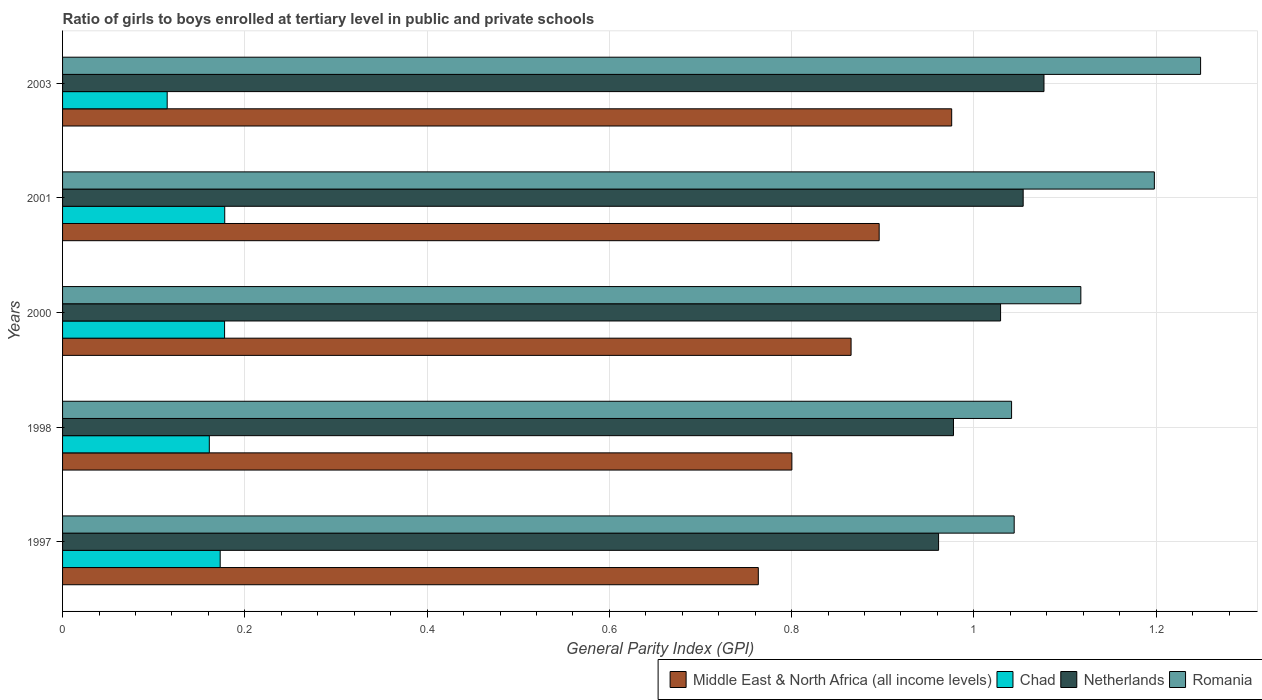Are the number of bars per tick equal to the number of legend labels?
Give a very brief answer. Yes. How many bars are there on the 4th tick from the top?
Provide a succinct answer. 4. How many bars are there on the 5th tick from the bottom?
Give a very brief answer. 4. What is the label of the 5th group of bars from the top?
Give a very brief answer. 1997. In how many cases, is the number of bars for a given year not equal to the number of legend labels?
Offer a terse response. 0. What is the general parity index in Chad in 2000?
Provide a short and direct response. 0.18. Across all years, what is the maximum general parity index in Romania?
Give a very brief answer. 1.25. Across all years, what is the minimum general parity index in Netherlands?
Your answer should be compact. 0.96. What is the total general parity index in Netherlands in the graph?
Your response must be concise. 5.1. What is the difference between the general parity index in Romania in 1997 and that in 2000?
Make the answer very short. -0.07. What is the difference between the general parity index in Middle East & North Africa (all income levels) in 1998 and the general parity index in Romania in 2001?
Your answer should be very brief. -0.4. What is the average general parity index in Middle East & North Africa (all income levels) per year?
Offer a very short reply. 0.86. In the year 2001, what is the difference between the general parity index in Middle East & North Africa (all income levels) and general parity index in Netherlands?
Your answer should be very brief. -0.16. What is the ratio of the general parity index in Romania in 1997 to that in 2000?
Offer a very short reply. 0.93. What is the difference between the highest and the second highest general parity index in Middle East & North Africa (all income levels)?
Your answer should be very brief. 0.08. What is the difference between the highest and the lowest general parity index in Chad?
Your answer should be compact. 0.06. In how many years, is the general parity index in Chad greater than the average general parity index in Chad taken over all years?
Your answer should be very brief. 4. What does the 3rd bar from the top in 2000 represents?
Ensure brevity in your answer.  Chad. What does the 2nd bar from the bottom in 2000 represents?
Offer a terse response. Chad. How many bars are there?
Your answer should be compact. 20. What is the difference between two consecutive major ticks on the X-axis?
Provide a succinct answer. 0.2. Are the values on the major ticks of X-axis written in scientific E-notation?
Your response must be concise. No. Does the graph contain any zero values?
Offer a terse response. No. Does the graph contain grids?
Provide a short and direct response. Yes. Where does the legend appear in the graph?
Your response must be concise. Bottom right. How are the legend labels stacked?
Offer a very short reply. Horizontal. What is the title of the graph?
Your response must be concise. Ratio of girls to boys enrolled at tertiary level in public and private schools. Does "Burundi" appear as one of the legend labels in the graph?
Your answer should be compact. No. What is the label or title of the X-axis?
Offer a terse response. General Parity Index (GPI). What is the label or title of the Y-axis?
Make the answer very short. Years. What is the General Parity Index (GPI) of Middle East & North Africa (all income levels) in 1997?
Offer a very short reply. 0.76. What is the General Parity Index (GPI) of Chad in 1997?
Your answer should be compact. 0.17. What is the General Parity Index (GPI) of Netherlands in 1997?
Your answer should be compact. 0.96. What is the General Parity Index (GPI) in Romania in 1997?
Give a very brief answer. 1.04. What is the General Parity Index (GPI) of Middle East & North Africa (all income levels) in 1998?
Give a very brief answer. 0.8. What is the General Parity Index (GPI) of Chad in 1998?
Your answer should be compact. 0.16. What is the General Parity Index (GPI) in Netherlands in 1998?
Your response must be concise. 0.98. What is the General Parity Index (GPI) in Romania in 1998?
Your answer should be very brief. 1.04. What is the General Parity Index (GPI) in Middle East & North Africa (all income levels) in 2000?
Give a very brief answer. 0.87. What is the General Parity Index (GPI) of Chad in 2000?
Your answer should be very brief. 0.18. What is the General Parity Index (GPI) of Netherlands in 2000?
Provide a short and direct response. 1.03. What is the General Parity Index (GPI) of Romania in 2000?
Your response must be concise. 1.12. What is the General Parity Index (GPI) in Middle East & North Africa (all income levels) in 2001?
Your answer should be very brief. 0.9. What is the General Parity Index (GPI) of Chad in 2001?
Your answer should be compact. 0.18. What is the General Parity Index (GPI) of Netherlands in 2001?
Your answer should be very brief. 1.05. What is the General Parity Index (GPI) in Romania in 2001?
Offer a very short reply. 1.2. What is the General Parity Index (GPI) in Middle East & North Africa (all income levels) in 2003?
Your answer should be very brief. 0.98. What is the General Parity Index (GPI) in Chad in 2003?
Offer a terse response. 0.11. What is the General Parity Index (GPI) in Netherlands in 2003?
Your answer should be compact. 1.08. What is the General Parity Index (GPI) in Romania in 2003?
Ensure brevity in your answer.  1.25. Across all years, what is the maximum General Parity Index (GPI) of Middle East & North Africa (all income levels)?
Your answer should be very brief. 0.98. Across all years, what is the maximum General Parity Index (GPI) of Chad?
Provide a short and direct response. 0.18. Across all years, what is the maximum General Parity Index (GPI) in Netherlands?
Provide a succinct answer. 1.08. Across all years, what is the maximum General Parity Index (GPI) of Romania?
Provide a succinct answer. 1.25. Across all years, what is the minimum General Parity Index (GPI) of Middle East & North Africa (all income levels)?
Keep it short and to the point. 0.76. Across all years, what is the minimum General Parity Index (GPI) of Chad?
Provide a short and direct response. 0.11. Across all years, what is the minimum General Parity Index (GPI) of Netherlands?
Keep it short and to the point. 0.96. Across all years, what is the minimum General Parity Index (GPI) in Romania?
Offer a terse response. 1.04. What is the total General Parity Index (GPI) of Middle East & North Africa (all income levels) in the graph?
Your answer should be compact. 4.3. What is the total General Parity Index (GPI) in Chad in the graph?
Provide a short and direct response. 0.8. What is the total General Parity Index (GPI) of Netherlands in the graph?
Your answer should be compact. 5.1. What is the total General Parity Index (GPI) in Romania in the graph?
Provide a short and direct response. 5.65. What is the difference between the General Parity Index (GPI) in Middle East & North Africa (all income levels) in 1997 and that in 1998?
Offer a very short reply. -0.04. What is the difference between the General Parity Index (GPI) of Chad in 1997 and that in 1998?
Provide a short and direct response. 0.01. What is the difference between the General Parity Index (GPI) of Netherlands in 1997 and that in 1998?
Provide a succinct answer. -0.02. What is the difference between the General Parity Index (GPI) of Romania in 1997 and that in 1998?
Keep it short and to the point. 0. What is the difference between the General Parity Index (GPI) in Middle East & North Africa (all income levels) in 1997 and that in 2000?
Your answer should be compact. -0.1. What is the difference between the General Parity Index (GPI) of Chad in 1997 and that in 2000?
Provide a succinct answer. -0. What is the difference between the General Parity Index (GPI) in Netherlands in 1997 and that in 2000?
Keep it short and to the point. -0.07. What is the difference between the General Parity Index (GPI) in Romania in 1997 and that in 2000?
Give a very brief answer. -0.07. What is the difference between the General Parity Index (GPI) of Middle East & North Africa (all income levels) in 1997 and that in 2001?
Your answer should be compact. -0.13. What is the difference between the General Parity Index (GPI) in Chad in 1997 and that in 2001?
Provide a succinct answer. -0.01. What is the difference between the General Parity Index (GPI) in Netherlands in 1997 and that in 2001?
Provide a short and direct response. -0.09. What is the difference between the General Parity Index (GPI) in Romania in 1997 and that in 2001?
Your answer should be compact. -0.15. What is the difference between the General Parity Index (GPI) of Middle East & North Africa (all income levels) in 1997 and that in 2003?
Keep it short and to the point. -0.21. What is the difference between the General Parity Index (GPI) of Chad in 1997 and that in 2003?
Keep it short and to the point. 0.06. What is the difference between the General Parity Index (GPI) in Netherlands in 1997 and that in 2003?
Make the answer very short. -0.12. What is the difference between the General Parity Index (GPI) of Romania in 1997 and that in 2003?
Provide a short and direct response. -0.2. What is the difference between the General Parity Index (GPI) in Middle East & North Africa (all income levels) in 1998 and that in 2000?
Provide a succinct answer. -0.07. What is the difference between the General Parity Index (GPI) of Chad in 1998 and that in 2000?
Your answer should be very brief. -0.02. What is the difference between the General Parity Index (GPI) of Netherlands in 1998 and that in 2000?
Your answer should be compact. -0.05. What is the difference between the General Parity Index (GPI) in Romania in 1998 and that in 2000?
Your answer should be very brief. -0.08. What is the difference between the General Parity Index (GPI) in Middle East & North Africa (all income levels) in 1998 and that in 2001?
Offer a terse response. -0.1. What is the difference between the General Parity Index (GPI) in Chad in 1998 and that in 2001?
Offer a terse response. -0.02. What is the difference between the General Parity Index (GPI) of Netherlands in 1998 and that in 2001?
Your answer should be compact. -0.08. What is the difference between the General Parity Index (GPI) of Romania in 1998 and that in 2001?
Your answer should be very brief. -0.16. What is the difference between the General Parity Index (GPI) in Middle East & North Africa (all income levels) in 1998 and that in 2003?
Provide a short and direct response. -0.18. What is the difference between the General Parity Index (GPI) of Chad in 1998 and that in 2003?
Make the answer very short. 0.05. What is the difference between the General Parity Index (GPI) of Netherlands in 1998 and that in 2003?
Ensure brevity in your answer.  -0.1. What is the difference between the General Parity Index (GPI) in Romania in 1998 and that in 2003?
Ensure brevity in your answer.  -0.21. What is the difference between the General Parity Index (GPI) in Middle East & North Africa (all income levels) in 2000 and that in 2001?
Offer a very short reply. -0.03. What is the difference between the General Parity Index (GPI) of Chad in 2000 and that in 2001?
Your response must be concise. -0. What is the difference between the General Parity Index (GPI) in Netherlands in 2000 and that in 2001?
Offer a very short reply. -0.02. What is the difference between the General Parity Index (GPI) of Romania in 2000 and that in 2001?
Ensure brevity in your answer.  -0.08. What is the difference between the General Parity Index (GPI) of Middle East & North Africa (all income levels) in 2000 and that in 2003?
Keep it short and to the point. -0.11. What is the difference between the General Parity Index (GPI) in Chad in 2000 and that in 2003?
Give a very brief answer. 0.06. What is the difference between the General Parity Index (GPI) in Netherlands in 2000 and that in 2003?
Your answer should be very brief. -0.05. What is the difference between the General Parity Index (GPI) of Romania in 2000 and that in 2003?
Offer a terse response. -0.13. What is the difference between the General Parity Index (GPI) in Middle East & North Africa (all income levels) in 2001 and that in 2003?
Provide a succinct answer. -0.08. What is the difference between the General Parity Index (GPI) of Chad in 2001 and that in 2003?
Your answer should be very brief. 0.06. What is the difference between the General Parity Index (GPI) in Netherlands in 2001 and that in 2003?
Provide a succinct answer. -0.02. What is the difference between the General Parity Index (GPI) in Romania in 2001 and that in 2003?
Your answer should be compact. -0.05. What is the difference between the General Parity Index (GPI) in Middle East & North Africa (all income levels) in 1997 and the General Parity Index (GPI) in Chad in 1998?
Keep it short and to the point. 0.6. What is the difference between the General Parity Index (GPI) of Middle East & North Africa (all income levels) in 1997 and the General Parity Index (GPI) of Netherlands in 1998?
Offer a very short reply. -0.21. What is the difference between the General Parity Index (GPI) in Middle East & North Africa (all income levels) in 1997 and the General Parity Index (GPI) in Romania in 1998?
Provide a short and direct response. -0.28. What is the difference between the General Parity Index (GPI) of Chad in 1997 and the General Parity Index (GPI) of Netherlands in 1998?
Your answer should be compact. -0.8. What is the difference between the General Parity Index (GPI) in Chad in 1997 and the General Parity Index (GPI) in Romania in 1998?
Give a very brief answer. -0.87. What is the difference between the General Parity Index (GPI) in Netherlands in 1997 and the General Parity Index (GPI) in Romania in 1998?
Give a very brief answer. -0.08. What is the difference between the General Parity Index (GPI) in Middle East & North Africa (all income levels) in 1997 and the General Parity Index (GPI) in Chad in 2000?
Keep it short and to the point. 0.59. What is the difference between the General Parity Index (GPI) in Middle East & North Africa (all income levels) in 1997 and the General Parity Index (GPI) in Netherlands in 2000?
Your response must be concise. -0.27. What is the difference between the General Parity Index (GPI) of Middle East & North Africa (all income levels) in 1997 and the General Parity Index (GPI) of Romania in 2000?
Provide a short and direct response. -0.35. What is the difference between the General Parity Index (GPI) in Chad in 1997 and the General Parity Index (GPI) in Netherlands in 2000?
Ensure brevity in your answer.  -0.86. What is the difference between the General Parity Index (GPI) of Chad in 1997 and the General Parity Index (GPI) of Romania in 2000?
Offer a very short reply. -0.94. What is the difference between the General Parity Index (GPI) in Netherlands in 1997 and the General Parity Index (GPI) in Romania in 2000?
Provide a succinct answer. -0.16. What is the difference between the General Parity Index (GPI) of Middle East & North Africa (all income levels) in 1997 and the General Parity Index (GPI) of Chad in 2001?
Offer a very short reply. 0.59. What is the difference between the General Parity Index (GPI) in Middle East & North Africa (all income levels) in 1997 and the General Parity Index (GPI) in Netherlands in 2001?
Your answer should be very brief. -0.29. What is the difference between the General Parity Index (GPI) in Middle East & North Africa (all income levels) in 1997 and the General Parity Index (GPI) in Romania in 2001?
Keep it short and to the point. -0.43. What is the difference between the General Parity Index (GPI) of Chad in 1997 and the General Parity Index (GPI) of Netherlands in 2001?
Keep it short and to the point. -0.88. What is the difference between the General Parity Index (GPI) of Chad in 1997 and the General Parity Index (GPI) of Romania in 2001?
Your response must be concise. -1.03. What is the difference between the General Parity Index (GPI) of Netherlands in 1997 and the General Parity Index (GPI) of Romania in 2001?
Provide a succinct answer. -0.24. What is the difference between the General Parity Index (GPI) in Middle East & North Africa (all income levels) in 1997 and the General Parity Index (GPI) in Chad in 2003?
Ensure brevity in your answer.  0.65. What is the difference between the General Parity Index (GPI) of Middle East & North Africa (all income levels) in 1997 and the General Parity Index (GPI) of Netherlands in 2003?
Your answer should be compact. -0.31. What is the difference between the General Parity Index (GPI) in Middle East & North Africa (all income levels) in 1997 and the General Parity Index (GPI) in Romania in 2003?
Provide a succinct answer. -0.49. What is the difference between the General Parity Index (GPI) in Chad in 1997 and the General Parity Index (GPI) in Netherlands in 2003?
Offer a very short reply. -0.9. What is the difference between the General Parity Index (GPI) of Chad in 1997 and the General Parity Index (GPI) of Romania in 2003?
Keep it short and to the point. -1.08. What is the difference between the General Parity Index (GPI) of Netherlands in 1997 and the General Parity Index (GPI) of Romania in 2003?
Your answer should be compact. -0.29. What is the difference between the General Parity Index (GPI) of Middle East & North Africa (all income levels) in 1998 and the General Parity Index (GPI) of Chad in 2000?
Ensure brevity in your answer.  0.62. What is the difference between the General Parity Index (GPI) of Middle East & North Africa (all income levels) in 1998 and the General Parity Index (GPI) of Netherlands in 2000?
Your answer should be compact. -0.23. What is the difference between the General Parity Index (GPI) of Middle East & North Africa (all income levels) in 1998 and the General Parity Index (GPI) of Romania in 2000?
Offer a very short reply. -0.32. What is the difference between the General Parity Index (GPI) of Chad in 1998 and the General Parity Index (GPI) of Netherlands in 2000?
Offer a very short reply. -0.87. What is the difference between the General Parity Index (GPI) of Chad in 1998 and the General Parity Index (GPI) of Romania in 2000?
Your answer should be compact. -0.96. What is the difference between the General Parity Index (GPI) in Netherlands in 1998 and the General Parity Index (GPI) in Romania in 2000?
Your answer should be very brief. -0.14. What is the difference between the General Parity Index (GPI) of Middle East & North Africa (all income levels) in 1998 and the General Parity Index (GPI) of Chad in 2001?
Offer a very short reply. 0.62. What is the difference between the General Parity Index (GPI) in Middle East & North Africa (all income levels) in 1998 and the General Parity Index (GPI) in Netherlands in 2001?
Provide a succinct answer. -0.25. What is the difference between the General Parity Index (GPI) in Middle East & North Africa (all income levels) in 1998 and the General Parity Index (GPI) in Romania in 2001?
Offer a very short reply. -0.4. What is the difference between the General Parity Index (GPI) of Chad in 1998 and the General Parity Index (GPI) of Netherlands in 2001?
Make the answer very short. -0.89. What is the difference between the General Parity Index (GPI) of Chad in 1998 and the General Parity Index (GPI) of Romania in 2001?
Give a very brief answer. -1.04. What is the difference between the General Parity Index (GPI) in Netherlands in 1998 and the General Parity Index (GPI) in Romania in 2001?
Your response must be concise. -0.22. What is the difference between the General Parity Index (GPI) in Middle East & North Africa (all income levels) in 1998 and the General Parity Index (GPI) in Chad in 2003?
Give a very brief answer. 0.69. What is the difference between the General Parity Index (GPI) of Middle East & North Africa (all income levels) in 1998 and the General Parity Index (GPI) of Netherlands in 2003?
Ensure brevity in your answer.  -0.28. What is the difference between the General Parity Index (GPI) in Middle East & North Africa (all income levels) in 1998 and the General Parity Index (GPI) in Romania in 2003?
Your answer should be compact. -0.45. What is the difference between the General Parity Index (GPI) of Chad in 1998 and the General Parity Index (GPI) of Netherlands in 2003?
Your answer should be compact. -0.92. What is the difference between the General Parity Index (GPI) of Chad in 1998 and the General Parity Index (GPI) of Romania in 2003?
Provide a succinct answer. -1.09. What is the difference between the General Parity Index (GPI) of Netherlands in 1998 and the General Parity Index (GPI) of Romania in 2003?
Give a very brief answer. -0.27. What is the difference between the General Parity Index (GPI) in Middle East & North Africa (all income levels) in 2000 and the General Parity Index (GPI) in Chad in 2001?
Your answer should be very brief. 0.69. What is the difference between the General Parity Index (GPI) in Middle East & North Africa (all income levels) in 2000 and the General Parity Index (GPI) in Netherlands in 2001?
Your response must be concise. -0.19. What is the difference between the General Parity Index (GPI) in Middle East & North Africa (all income levels) in 2000 and the General Parity Index (GPI) in Romania in 2001?
Ensure brevity in your answer.  -0.33. What is the difference between the General Parity Index (GPI) in Chad in 2000 and the General Parity Index (GPI) in Netherlands in 2001?
Ensure brevity in your answer.  -0.88. What is the difference between the General Parity Index (GPI) of Chad in 2000 and the General Parity Index (GPI) of Romania in 2001?
Your answer should be very brief. -1.02. What is the difference between the General Parity Index (GPI) in Netherlands in 2000 and the General Parity Index (GPI) in Romania in 2001?
Provide a succinct answer. -0.17. What is the difference between the General Parity Index (GPI) in Middle East & North Africa (all income levels) in 2000 and the General Parity Index (GPI) in Chad in 2003?
Offer a very short reply. 0.75. What is the difference between the General Parity Index (GPI) in Middle East & North Africa (all income levels) in 2000 and the General Parity Index (GPI) in Netherlands in 2003?
Your answer should be compact. -0.21. What is the difference between the General Parity Index (GPI) in Middle East & North Africa (all income levels) in 2000 and the General Parity Index (GPI) in Romania in 2003?
Give a very brief answer. -0.38. What is the difference between the General Parity Index (GPI) in Chad in 2000 and the General Parity Index (GPI) in Netherlands in 2003?
Provide a short and direct response. -0.9. What is the difference between the General Parity Index (GPI) of Chad in 2000 and the General Parity Index (GPI) of Romania in 2003?
Give a very brief answer. -1.07. What is the difference between the General Parity Index (GPI) of Netherlands in 2000 and the General Parity Index (GPI) of Romania in 2003?
Your answer should be very brief. -0.22. What is the difference between the General Parity Index (GPI) of Middle East & North Africa (all income levels) in 2001 and the General Parity Index (GPI) of Chad in 2003?
Give a very brief answer. 0.78. What is the difference between the General Parity Index (GPI) of Middle East & North Africa (all income levels) in 2001 and the General Parity Index (GPI) of Netherlands in 2003?
Give a very brief answer. -0.18. What is the difference between the General Parity Index (GPI) in Middle East & North Africa (all income levels) in 2001 and the General Parity Index (GPI) in Romania in 2003?
Keep it short and to the point. -0.35. What is the difference between the General Parity Index (GPI) in Chad in 2001 and the General Parity Index (GPI) in Netherlands in 2003?
Ensure brevity in your answer.  -0.9. What is the difference between the General Parity Index (GPI) of Chad in 2001 and the General Parity Index (GPI) of Romania in 2003?
Offer a very short reply. -1.07. What is the difference between the General Parity Index (GPI) in Netherlands in 2001 and the General Parity Index (GPI) in Romania in 2003?
Offer a very short reply. -0.19. What is the average General Parity Index (GPI) of Middle East & North Africa (all income levels) per year?
Give a very brief answer. 0.86. What is the average General Parity Index (GPI) of Chad per year?
Provide a short and direct response. 0.16. What is the average General Parity Index (GPI) of Netherlands per year?
Provide a short and direct response. 1.02. What is the average General Parity Index (GPI) in Romania per year?
Offer a very short reply. 1.13. In the year 1997, what is the difference between the General Parity Index (GPI) of Middle East & North Africa (all income levels) and General Parity Index (GPI) of Chad?
Your answer should be very brief. 0.59. In the year 1997, what is the difference between the General Parity Index (GPI) in Middle East & North Africa (all income levels) and General Parity Index (GPI) in Netherlands?
Keep it short and to the point. -0.2. In the year 1997, what is the difference between the General Parity Index (GPI) of Middle East & North Africa (all income levels) and General Parity Index (GPI) of Romania?
Ensure brevity in your answer.  -0.28. In the year 1997, what is the difference between the General Parity Index (GPI) in Chad and General Parity Index (GPI) in Netherlands?
Your response must be concise. -0.79. In the year 1997, what is the difference between the General Parity Index (GPI) in Chad and General Parity Index (GPI) in Romania?
Your answer should be compact. -0.87. In the year 1997, what is the difference between the General Parity Index (GPI) in Netherlands and General Parity Index (GPI) in Romania?
Give a very brief answer. -0.08. In the year 1998, what is the difference between the General Parity Index (GPI) in Middle East & North Africa (all income levels) and General Parity Index (GPI) in Chad?
Provide a succinct answer. 0.64. In the year 1998, what is the difference between the General Parity Index (GPI) in Middle East & North Africa (all income levels) and General Parity Index (GPI) in Netherlands?
Provide a succinct answer. -0.18. In the year 1998, what is the difference between the General Parity Index (GPI) in Middle East & North Africa (all income levels) and General Parity Index (GPI) in Romania?
Give a very brief answer. -0.24. In the year 1998, what is the difference between the General Parity Index (GPI) in Chad and General Parity Index (GPI) in Netherlands?
Keep it short and to the point. -0.82. In the year 1998, what is the difference between the General Parity Index (GPI) of Chad and General Parity Index (GPI) of Romania?
Your answer should be very brief. -0.88. In the year 1998, what is the difference between the General Parity Index (GPI) in Netherlands and General Parity Index (GPI) in Romania?
Offer a terse response. -0.06. In the year 2000, what is the difference between the General Parity Index (GPI) in Middle East & North Africa (all income levels) and General Parity Index (GPI) in Chad?
Your answer should be very brief. 0.69. In the year 2000, what is the difference between the General Parity Index (GPI) of Middle East & North Africa (all income levels) and General Parity Index (GPI) of Netherlands?
Give a very brief answer. -0.16. In the year 2000, what is the difference between the General Parity Index (GPI) in Middle East & North Africa (all income levels) and General Parity Index (GPI) in Romania?
Your response must be concise. -0.25. In the year 2000, what is the difference between the General Parity Index (GPI) in Chad and General Parity Index (GPI) in Netherlands?
Offer a terse response. -0.85. In the year 2000, what is the difference between the General Parity Index (GPI) in Chad and General Parity Index (GPI) in Romania?
Provide a succinct answer. -0.94. In the year 2000, what is the difference between the General Parity Index (GPI) in Netherlands and General Parity Index (GPI) in Romania?
Provide a succinct answer. -0.09. In the year 2001, what is the difference between the General Parity Index (GPI) in Middle East & North Africa (all income levels) and General Parity Index (GPI) in Chad?
Provide a succinct answer. 0.72. In the year 2001, what is the difference between the General Parity Index (GPI) of Middle East & North Africa (all income levels) and General Parity Index (GPI) of Netherlands?
Your response must be concise. -0.16. In the year 2001, what is the difference between the General Parity Index (GPI) of Middle East & North Africa (all income levels) and General Parity Index (GPI) of Romania?
Provide a short and direct response. -0.3. In the year 2001, what is the difference between the General Parity Index (GPI) in Chad and General Parity Index (GPI) in Netherlands?
Keep it short and to the point. -0.88. In the year 2001, what is the difference between the General Parity Index (GPI) in Chad and General Parity Index (GPI) in Romania?
Offer a very short reply. -1.02. In the year 2001, what is the difference between the General Parity Index (GPI) in Netherlands and General Parity Index (GPI) in Romania?
Your answer should be compact. -0.14. In the year 2003, what is the difference between the General Parity Index (GPI) of Middle East & North Africa (all income levels) and General Parity Index (GPI) of Chad?
Offer a very short reply. 0.86. In the year 2003, what is the difference between the General Parity Index (GPI) of Middle East & North Africa (all income levels) and General Parity Index (GPI) of Netherlands?
Your response must be concise. -0.1. In the year 2003, what is the difference between the General Parity Index (GPI) in Middle East & North Africa (all income levels) and General Parity Index (GPI) in Romania?
Your answer should be very brief. -0.27. In the year 2003, what is the difference between the General Parity Index (GPI) of Chad and General Parity Index (GPI) of Netherlands?
Keep it short and to the point. -0.96. In the year 2003, what is the difference between the General Parity Index (GPI) in Chad and General Parity Index (GPI) in Romania?
Ensure brevity in your answer.  -1.13. In the year 2003, what is the difference between the General Parity Index (GPI) in Netherlands and General Parity Index (GPI) in Romania?
Offer a very short reply. -0.17. What is the ratio of the General Parity Index (GPI) of Middle East & North Africa (all income levels) in 1997 to that in 1998?
Keep it short and to the point. 0.95. What is the ratio of the General Parity Index (GPI) of Chad in 1997 to that in 1998?
Keep it short and to the point. 1.07. What is the ratio of the General Parity Index (GPI) in Netherlands in 1997 to that in 1998?
Keep it short and to the point. 0.98. What is the ratio of the General Parity Index (GPI) of Romania in 1997 to that in 1998?
Provide a succinct answer. 1. What is the ratio of the General Parity Index (GPI) in Middle East & North Africa (all income levels) in 1997 to that in 2000?
Provide a short and direct response. 0.88. What is the ratio of the General Parity Index (GPI) in Chad in 1997 to that in 2000?
Give a very brief answer. 0.97. What is the ratio of the General Parity Index (GPI) of Netherlands in 1997 to that in 2000?
Make the answer very short. 0.93. What is the ratio of the General Parity Index (GPI) in Romania in 1997 to that in 2000?
Give a very brief answer. 0.93. What is the ratio of the General Parity Index (GPI) of Middle East & North Africa (all income levels) in 1997 to that in 2001?
Ensure brevity in your answer.  0.85. What is the ratio of the General Parity Index (GPI) in Chad in 1997 to that in 2001?
Your response must be concise. 0.97. What is the ratio of the General Parity Index (GPI) in Netherlands in 1997 to that in 2001?
Your answer should be very brief. 0.91. What is the ratio of the General Parity Index (GPI) in Romania in 1997 to that in 2001?
Provide a short and direct response. 0.87. What is the ratio of the General Parity Index (GPI) of Middle East & North Africa (all income levels) in 1997 to that in 2003?
Your answer should be compact. 0.78. What is the ratio of the General Parity Index (GPI) of Chad in 1997 to that in 2003?
Your answer should be very brief. 1.51. What is the ratio of the General Parity Index (GPI) of Netherlands in 1997 to that in 2003?
Provide a short and direct response. 0.89. What is the ratio of the General Parity Index (GPI) of Romania in 1997 to that in 2003?
Provide a succinct answer. 0.84. What is the ratio of the General Parity Index (GPI) in Middle East & North Africa (all income levels) in 1998 to that in 2000?
Your response must be concise. 0.92. What is the ratio of the General Parity Index (GPI) of Chad in 1998 to that in 2000?
Provide a short and direct response. 0.91. What is the ratio of the General Parity Index (GPI) of Netherlands in 1998 to that in 2000?
Offer a very short reply. 0.95. What is the ratio of the General Parity Index (GPI) of Romania in 1998 to that in 2000?
Your answer should be very brief. 0.93. What is the ratio of the General Parity Index (GPI) of Middle East & North Africa (all income levels) in 1998 to that in 2001?
Give a very brief answer. 0.89. What is the ratio of the General Parity Index (GPI) in Chad in 1998 to that in 2001?
Provide a short and direct response. 0.9. What is the ratio of the General Parity Index (GPI) in Netherlands in 1998 to that in 2001?
Provide a succinct answer. 0.93. What is the ratio of the General Parity Index (GPI) in Romania in 1998 to that in 2001?
Offer a very short reply. 0.87. What is the ratio of the General Parity Index (GPI) in Middle East & North Africa (all income levels) in 1998 to that in 2003?
Your response must be concise. 0.82. What is the ratio of the General Parity Index (GPI) of Chad in 1998 to that in 2003?
Your answer should be compact. 1.4. What is the ratio of the General Parity Index (GPI) of Netherlands in 1998 to that in 2003?
Provide a succinct answer. 0.91. What is the ratio of the General Parity Index (GPI) of Romania in 1998 to that in 2003?
Your response must be concise. 0.83. What is the ratio of the General Parity Index (GPI) of Middle East & North Africa (all income levels) in 2000 to that in 2001?
Your answer should be compact. 0.97. What is the ratio of the General Parity Index (GPI) of Netherlands in 2000 to that in 2001?
Offer a very short reply. 0.98. What is the ratio of the General Parity Index (GPI) of Romania in 2000 to that in 2001?
Keep it short and to the point. 0.93. What is the ratio of the General Parity Index (GPI) in Middle East & North Africa (all income levels) in 2000 to that in 2003?
Make the answer very short. 0.89. What is the ratio of the General Parity Index (GPI) in Chad in 2000 to that in 2003?
Provide a short and direct response. 1.55. What is the ratio of the General Parity Index (GPI) in Netherlands in 2000 to that in 2003?
Your answer should be very brief. 0.96. What is the ratio of the General Parity Index (GPI) in Romania in 2000 to that in 2003?
Ensure brevity in your answer.  0.89. What is the ratio of the General Parity Index (GPI) in Middle East & North Africa (all income levels) in 2001 to that in 2003?
Offer a terse response. 0.92. What is the ratio of the General Parity Index (GPI) in Chad in 2001 to that in 2003?
Make the answer very short. 1.55. What is the ratio of the General Parity Index (GPI) in Netherlands in 2001 to that in 2003?
Give a very brief answer. 0.98. What is the ratio of the General Parity Index (GPI) of Romania in 2001 to that in 2003?
Keep it short and to the point. 0.96. What is the difference between the highest and the second highest General Parity Index (GPI) of Middle East & North Africa (all income levels)?
Make the answer very short. 0.08. What is the difference between the highest and the second highest General Parity Index (GPI) of Netherlands?
Provide a short and direct response. 0.02. What is the difference between the highest and the second highest General Parity Index (GPI) in Romania?
Offer a very short reply. 0.05. What is the difference between the highest and the lowest General Parity Index (GPI) in Middle East & North Africa (all income levels)?
Give a very brief answer. 0.21. What is the difference between the highest and the lowest General Parity Index (GPI) of Chad?
Provide a short and direct response. 0.06. What is the difference between the highest and the lowest General Parity Index (GPI) of Netherlands?
Ensure brevity in your answer.  0.12. What is the difference between the highest and the lowest General Parity Index (GPI) in Romania?
Ensure brevity in your answer.  0.21. 